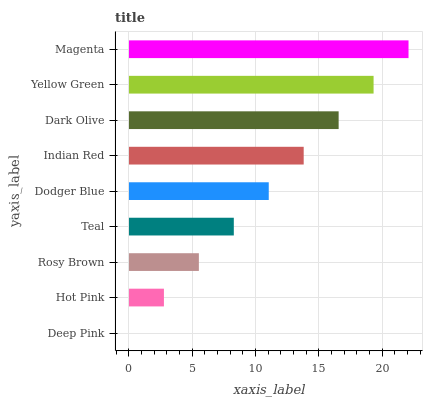Is Deep Pink the minimum?
Answer yes or no. Yes. Is Magenta the maximum?
Answer yes or no. Yes. Is Hot Pink the minimum?
Answer yes or no. No. Is Hot Pink the maximum?
Answer yes or no. No. Is Hot Pink greater than Deep Pink?
Answer yes or no. Yes. Is Deep Pink less than Hot Pink?
Answer yes or no. Yes. Is Deep Pink greater than Hot Pink?
Answer yes or no. No. Is Hot Pink less than Deep Pink?
Answer yes or no. No. Is Dodger Blue the high median?
Answer yes or no. Yes. Is Dodger Blue the low median?
Answer yes or no. Yes. Is Rosy Brown the high median?
Answer yes or no. No. Is Deep Pink the low median?
Answer yes or no. No. 